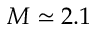Convert formula to latex. <formula><loc_0><loc_0><loc_500><loc_500>M \simeq 2 . 1</formula> 